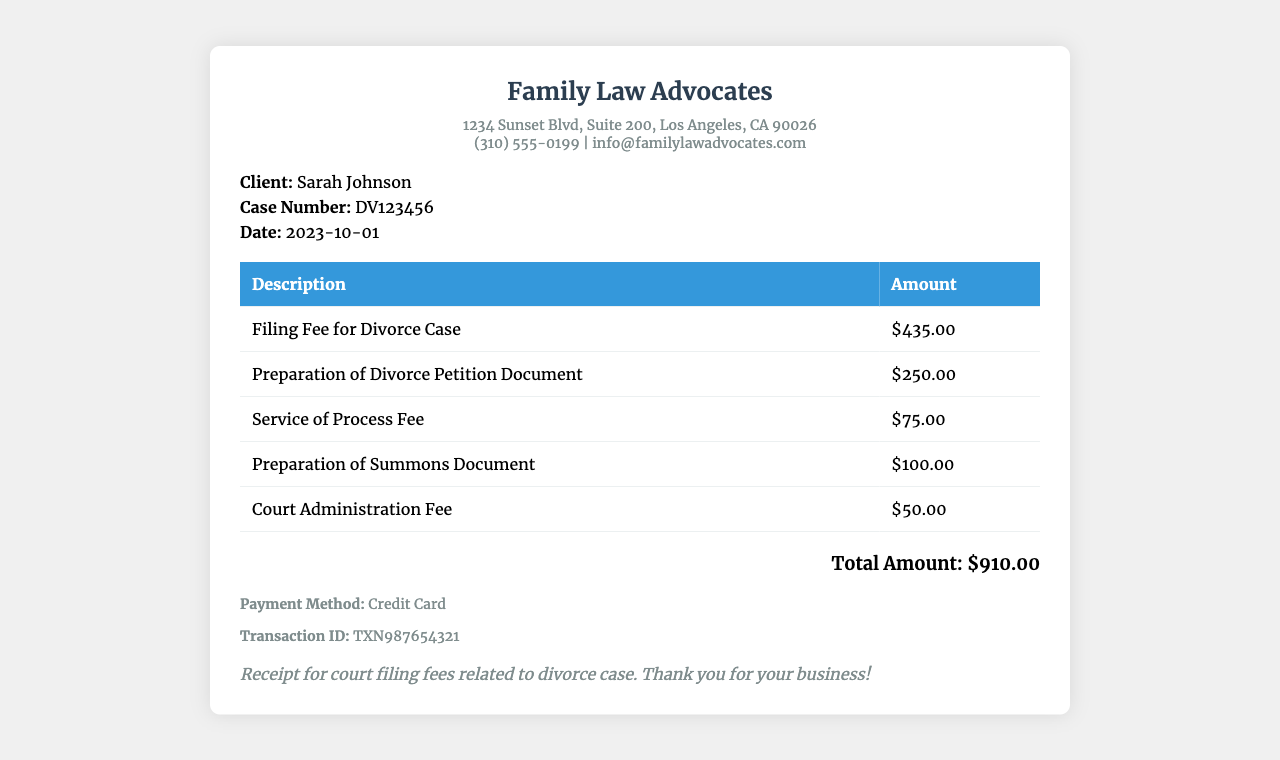What is the client's name? The client's name is clearly stated in the client information section of the document.
Answer: Sarah Johnson What was the case number? The case number is provided right below the client's name in the document.
Answer: DV123456 What is the date of the receipt? The date can be found in the client information section at the bottom.
Answer: 2023-10-01 What is the total amount charged? The total amount is summarized at the end of the receipt, representing the sum of all charges.
Answer: $910.00 How much is the filing fee for the divorce case? The specific amount for the filing fee is listed in the fees table of the document.
Answer: $435.00 What is the amount charged for the preparation of the divorce petition document? The amount for document preparation is listed next to the corresponding description in the table.
Answer: $250.00 What method of payment was used? The payment method is clearly indicated in the payment information section of the document.
Answer: Credit Card What was the transaction ID? The transaction ID is detailed in the payment information area of the receipt.
Answer: TXN987654321 How much was charged for the service of process fee? The fee amount for the service of process is listed in the table under its description.
Answer: $75.00 What is the purpose of this receipt? The purpose of the receipt is summarized in the notes section at the end of the document.
Answer: Receipt for court filing fees related to divorce case 